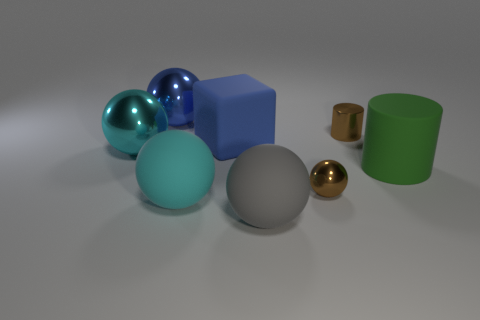Subtract all gray spheres. How many spheres are left? 4 Subtract all cyan shiny spheres. How many spheres are left? 4 Subtract all green spheres. Subtract all purple cylinders. How many spheres are left? 5 Add 1 small red matte spheres. How many objects exist? 9 Subtract all cubes. How many objects are left? 7 Add 7 red spheres. How many red spheres exist? 7 Subtract 0 brown cubes. How many objects are left? 8 Subtract all big cyan objects. Subtract all blue objects. How many objects are left? 4 Add 6 small metallic objects. How many small metallic objects are left? 8 